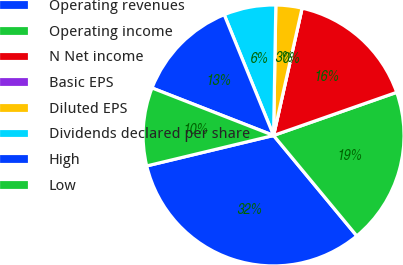Convert chart to OTSL. <chart><loc_0><loc_0><loc_500><loc_500><pie_chart><fcel>Operating revenues<fcel>Operating income<fcel>N Net income<fcel>Basic EPS<fcel>Diluted EPS<fcel>Dividends declared per share<fcel>High<fcel>Low<nl><fcel>32.26%<fcel>19.35%<fcel>16.13%<fcel>0.0%<fcel>3.23%<fcel>6.45%<fcel>12.9%<fcel>9.68%<nl></chart> 